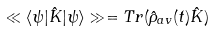<formula> <loc_0><loc_0><loc_500><loc_500>\ll \langle \psi | \hat { K } | \psi \rangle \gg = T r ( \hat { \rho } _ { a v } ( t ) \hat { K } )</formula> 